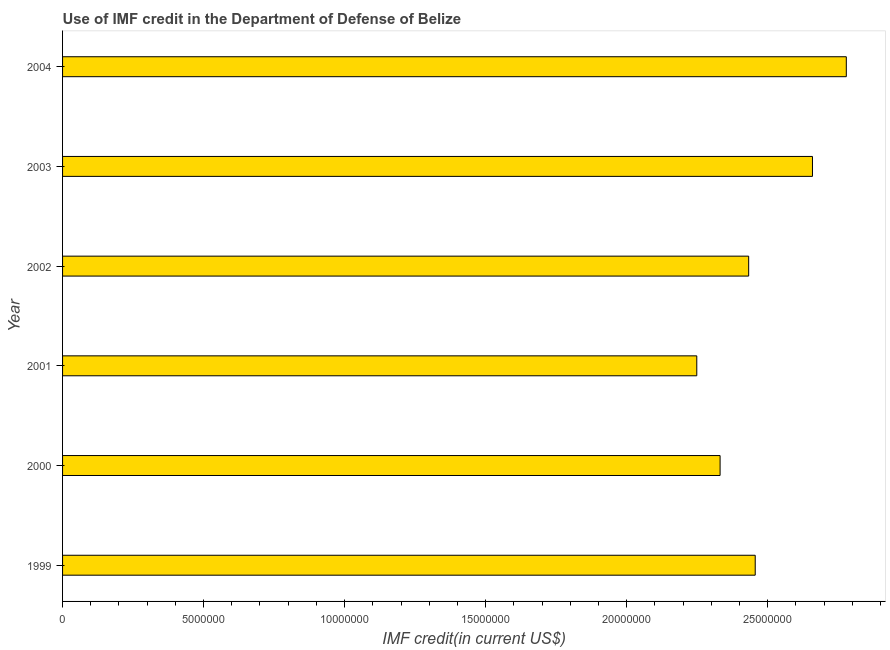Does the graph contain any zero values?
Your response must be concise. No. Does the graph contain grids?
Your answer should be very brief. No. What is the title of the graph?
Provide a succinct answer. Use of IMF credit in the Department of Defense of Belize. What is the label or title of the X-axis?
Ensure brevity in your answer.  IMF credit(in current US$). What is the use of imf credit in dod in 1999?
Make the answer very short. 2.46e+07. Across all years, what is the maximum use of imf credit in dod?
Offer a very short reply. 2.78e+07. Across all years, what is the minimum use of imf credit in dod?
Give a very brief answer. 2.25e+07. What is the sum of the use of imf credit in dod?
Your answer should be compact. 1.49e+08. What is the difference between the use of imf credit in dod in 2002 and 2004?
Keep it short and to the point. -3.46e+06. What is the average use of imf credit in dod per year?
Offer a terse response. 2.48e+07. What is the median use of imf credit in dod?
Ensure brevity in your answer.  2.44e+07. Do a majority of the years between 2003 and 2000 (inclusive) have use of imf credit in dod greater than 26000000 US$?
Offer a terse response. Yes. What is the ratio of the use of imf credit in dod in 2002 to that in 2003?
Your answer should be very brief. 0.92. Is the difference between the use of imf credit in dod in 1999 and 2000 greater than the difference between any two years?
Give a very brief answer. No. What is the difference between the highest and the second highest use of imf credit in dod?
Provide a succinct answer. 1.20e+06. What is the difference between the highest and the lowest use of imf credit in dod?
Your answer should be very brief. 5.30e+06. How many years are there in the graph?
Ensure brevity in your answer.  6. What is the difference between two consecutive major ticks on the X-axis?
Give a very brief answer. 5.00e+06. Are the values on the major ticks of X-axis written in scientific E-notation?
Offer a very short reply. No. What is the IMF credit(in current US$) in 1999?
Make the answer very short. 2.46e+07. What is the IMF credit(in current US$) in 2000?
Give a very brief answer. 2.33e+07. What is the IMF credit(in current US$) of 2001?
Offer a very short reply. 2.25e+07. What is the IMF credit(in current US$) of 2002?
Your answer should be compact. 2.43e+07. What is the IMF credit(in current US$) in 2003?
Keep it short and to the point. 2.66e+07. What is the IMF credit(in current US$) of 2004?
Keep it short and to the point. 2.78e+07. What is the difference between the IMF credit(in current US$) in 1999 and 2000?
Offer a terse response. 1.24e+06. What is the difference between the IMF credit(in current US$) in 1999 and 2001?
Provide a short and direct response. 2.07e+06. What is the difference between the IMF credit(in current US$) in 1999 and 2002?
Keep it short and to the point. 2.32e+05. What is the difference between the IMF credit(in current US$) in 1999 and 2003?
Give a very brief answer. -2.03e+06. What is the difference between the IMF credit(in current US$) in 1999 and 2004?
Provide a succinct answer. -3.23e+06. What is the difference between the IMF credit(in current US$) in 2000 and 2001?
Make the answer very short. 8.27e+05. What is the difference between the IMF credit(in current US$) in 2000 and 2002?
Your answer should be very brief. -1.01e+06. What is the difference between the IMF credit(in current US$) in 2000 and 2003?
Your response must be concise. -3.28e+06. What is the difference between the IMF credit(in current US$) in 2000 and 2004?
Offer a terse response. -4.48e+06. What is the difference between the IMF credit(in current US$) in 2001 and 2002?
Make the answer very short. -1.84e+06. What is the difference between the IMF credit(in current US$) in 2001 and 2003?
Offer a terse response. -4.10e+06. What is the difference between the IMF credit(in current US$) in 2001 and 2004?
Keep it short and to the point. -5.30e+06. What is the difference between the IMF credit(in current US$) in 2002 and 2003?
Your answer should be very brief. -2.26e+06. What is the difference between the IMF credit(in current US$) in 2002 and 2004?
Provide a succinct answer. -3.46e+06. What is the difference between the IMF credit(in current US$) in 2003 and 2004?
Give a very brief answer. -1.20e+06. What is the ratio of the IMF credit(in current US$) in 1999 to that in 2000?
Offer a very short reply. 1.05. What is the ratio of the IMF credit(in current US$) in 1999 to that in 2001?
Provide a succinct answer. 1.09. What is the ratio of the IMF credit(in current US$) in 1999 to that in 2002?
Provide a succinct answer. 1.01. What is the ratio of the IMF credit(in current US$) in 1999 to that in 2003?
Give a very brief answer. 0.92. What is the ratio of the IMF credit(in current US$) in 1999 to that in 2004?
Ensure brevity in your answer.  0.88. What is the ratio of the IMF credit(in current US$) in 2000 to that in 2001?
Keep it short and to the point. 1.04. What is the ratio of the IMF credit(in current US$) in 2000 to that in 2002?
Offer a very short reply. 0.96. What is the ratio of the IMF credit(in current US$) in 2000 to that in 2003?
Offer a very short reply. 0.88. What is the ratio of the IMF credit(in current US$) in 2000 to that in 2004?
Your answer should be compact. 0.84. What is the ratio of the IMF credit(in current US$) in 2001 to that in 2002?
Your answer should be very brief. 0.92. What is the ratio of the IMF credit(in current US$) in 2001 to that in 2003?
Give a very brief answer. 0.85. What is the ratio of the IMF credit(in current US$) in 2001 to that in 2004?
Your answer should be compact. 0.81. What is the ratio of the IMF credit(in current US$) in 2002 to that in 2003?
Offer a terse response. 0.92. What is the ratio of the IMF credit(in current US$) in 2002 to that in 2004?
Provide a short and direct response. 0.88. What is the ratio of the IMF credit(in current US$) in 2003 to that in 2004?
Give a very brief answer. 0.96. 